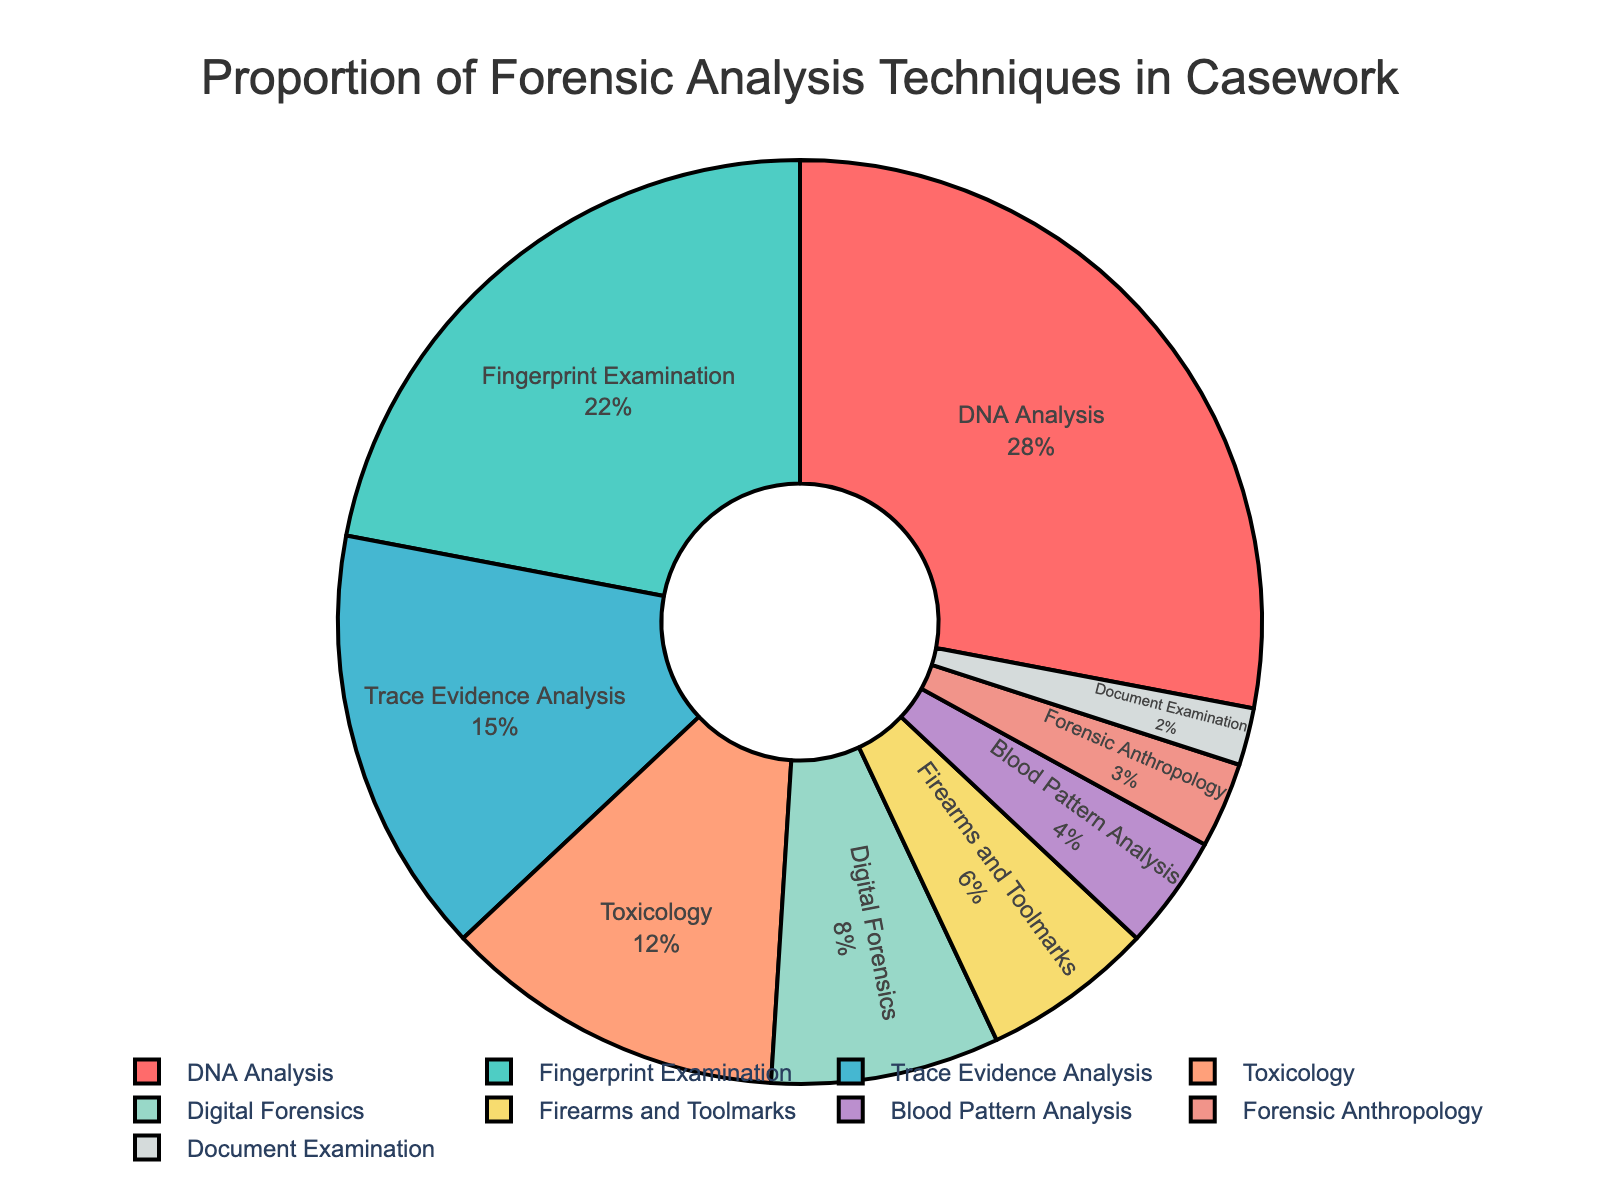What proportion of casework is handled by DNA Analysis? Look at the pie chart and identify the section labeled "DNA Analysis." It will have the percentage indicated.
Answer: 28% Which technique has the lowest proportion and what is it? Find the smallest slice of the pie chart and check the label.
Answer: Document Examination at 2% Comparing Fingerprint Examination and Trace Evidence Analysis, which is used more frequently and by how much? Identify the percentages for Fingerprint Examination and Trace Evidence Analysis from the chart. Subtract the smaller percentage from the larger.
Answer: Fingerprint Examination by 7% How much more is Digital Forensics used compared to Forensic Anthropology? Find and compare the percentages for Digital Forensics and Forensic Anthropology. Subtract the smaller percentage from the larger.
Answer: 5% What is the combined percentage of Toxicology and Blood Pattern Analysis? Locate the percentages for Toxicology and Blood Pattern Analysis. Add them up (12% + 4%).
Answer: 16% Which technique uses a red color in the pie chart? Refer to the segment of the pie chart colored red and identify the corresponding label.
Answer: DNA Analysis Between Trace Evidence Analysis and Firearms and Toolmarks, how many times greater is the proportion of Trace Evidence Analysis? Identify the percentages, then divide the percentage of Trace Evidence Analysis by that of Firearms and Toolmarks. (15% ÷ 6%).
Answer: 2.5 times Which technique occupies a middle position in terms of the proportion among all the techniques? Sort all techniques by their percentage values and identify the middle one.
Answer: Trace Evidence Analysis What is the total proportion of the top three techniques combined? Sum the percentages of DNA Analysis, Fingerprint Examination, and Trace Evidence Analysis. (28% + 22% + 15%).
Answer: 65% How does the proportion of Toxicology compare to Digital Forensics? Compare the percentages of Toxicology and Digital Forensics directly.
Answer: Toxicology is used 4% more than Digital Forensics 